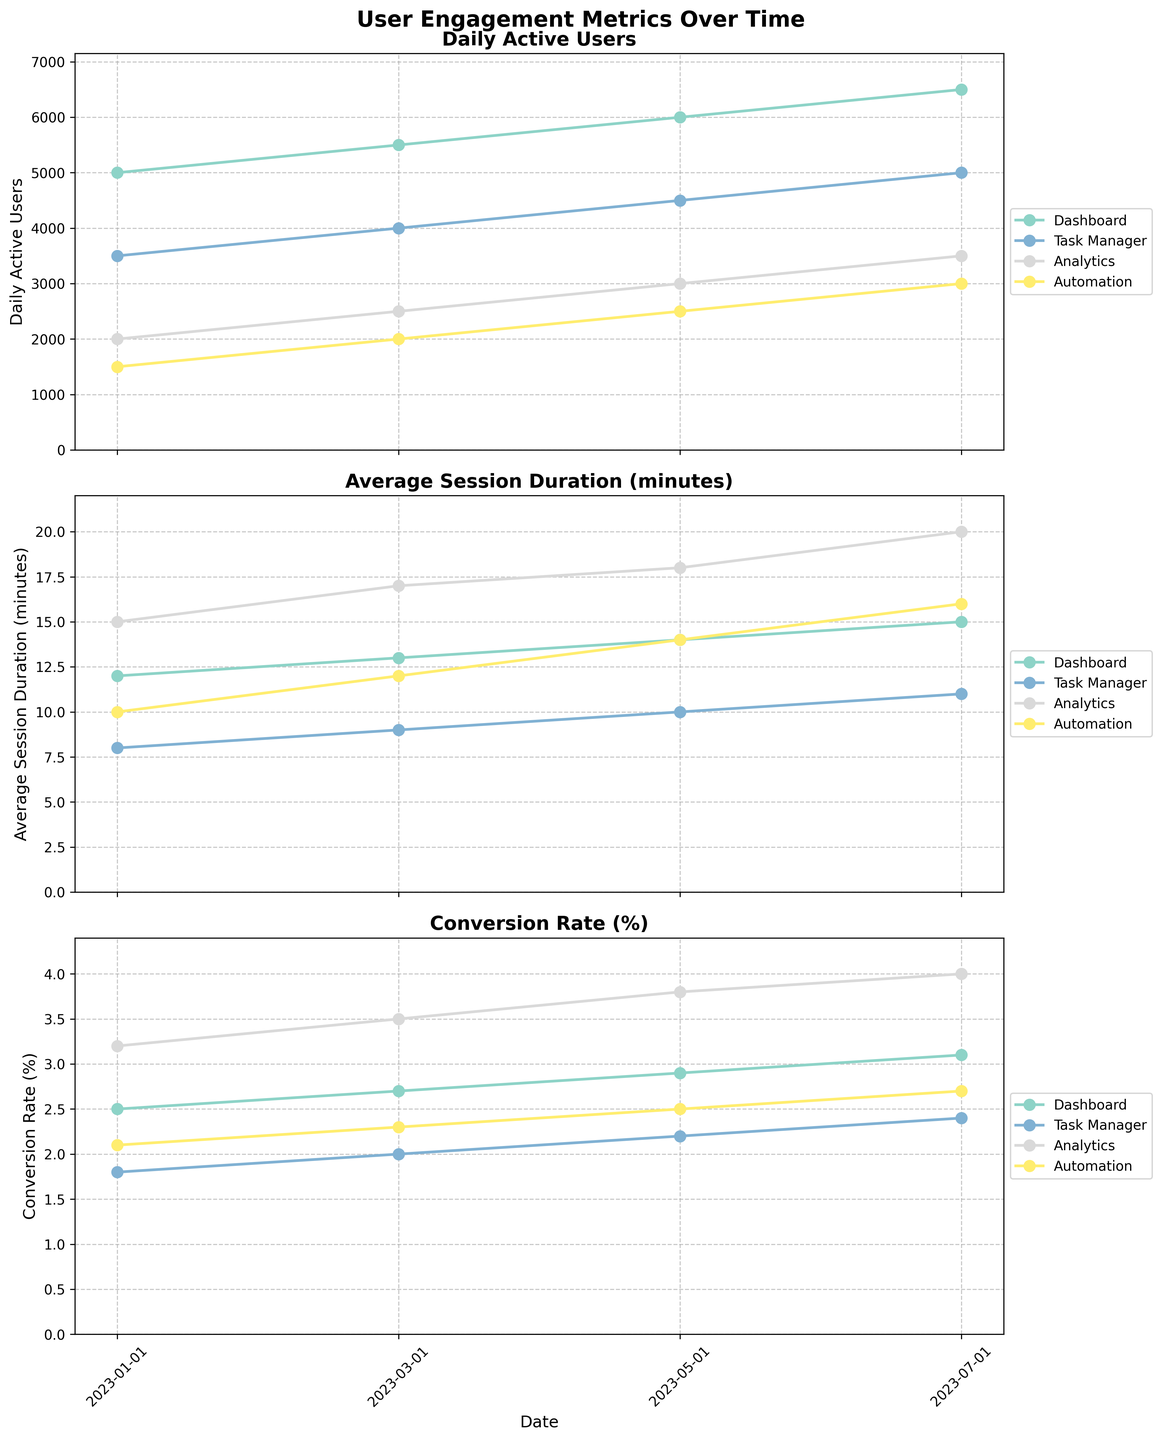What is the title of the figure? The title is located at the top of the figure and reads "User Engagement Metrics Over Time".
Answer: User Engagement Metrics Over Time What are the three metrics displayed in the subplots? By looking at the titles of each subplot, we can see that they are "Daily Active Users," "Average Session Duration (minutes)," and "Conversion Rate (%)".
Answer: Daily Active Users, Average Session Duration (minutes), Conversion Rate (%) Which feature has the highest Daily Active Users on 2023-07-01? In the "Daily Active Users" subplot, the highest point on 2023-07-01 corresponds to the "Dashboard" feature.
Answer: Dashboard How has the average session duration for the Analytics feature changed from 2023-01-01 to 2023-07-01? In the "Average Session Duration (minutes)" subplot, the values for the Analytics feature on the specified dates have increased from 15 minutes on 2023-01-01 to 20 minutes on 2023-07-01.
Answer: Increased from 15 to 20 minutes Which metric shows the highest value across all features and dates? In comparing the highest values across all metrics from all features and dates, it's evident that the "Daily Active Users" metric for the Dashboard feature on 2023-07-01 (6500 users) is the highest.
Answer: Daily Active Users for Dashboard Which feature shows the most consistent increase in Conversion Rate (%) over the time period? By examining the "Conversion Rate (%)" subplot, the "Analytics" feature consistently increases from 3.2% on 2023-01-01 to 4.0% on 2023-07-01.
Answer: Analytics Compare the increase in Daily Active Users for the Task Manager feature from 2023-01-01 to 2023-07-01. For the Task Manager feature, the Daily Active Users increase from 3500 on 2023-01-01 to 5000 on 2023-07-01, resulting in an increase of 1500.
Answer: Increased by 1500 What's the difference in average session duration between Dashboard and Automation features on 2023-05-01? In the "Average Session Duration (minutes)" subplot, for 2023-05-01, Dashboard is at 14 minutes, and Automation is at 14 minutes, making the difference 0.
Answer: 0 minutes Which feature has the lowest Conversion Rate (%) on 2023-01-01 and what is its value? On 2023-01-01, in the "Conversion Rate (%)" subplot, the Task Manager feature has the lowest value at 1.8%.
Answer: Task Manager, 1.8% 